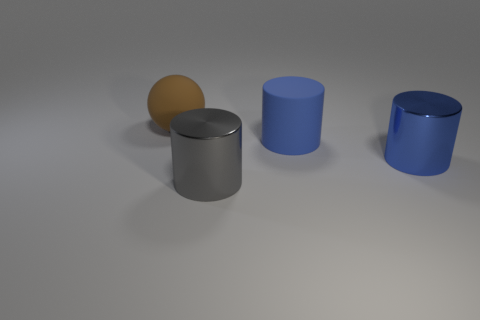There is another blue cylinder that is the same size as the rubber cylinder; what is it made of? metal 